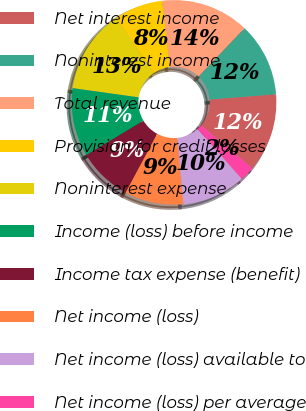<chart> <loc_0><loc_0><loc_500><loc_500><pie_chart><fcel>Net interest income<fcel>Noninterest income<fcel>Total revenue<fcel>Provision for credit losses<fcel>Noninterest expense<fcel>Income (loss) before income<fcel>Income tax expense (benefit)<fcel>Net income (loss)<fcel>Net income (loss) available to<fcel>Net income (loss) per average<nl><fcel>12.4%<fcel>11.63%<fcel>13.95%<fcel>7.75%<fcel>13.18%<fcel>10.85%<fcel>8.53%<fcel>9.3%<fcel>10.08%<fcel>2.33%<nl></chart> 